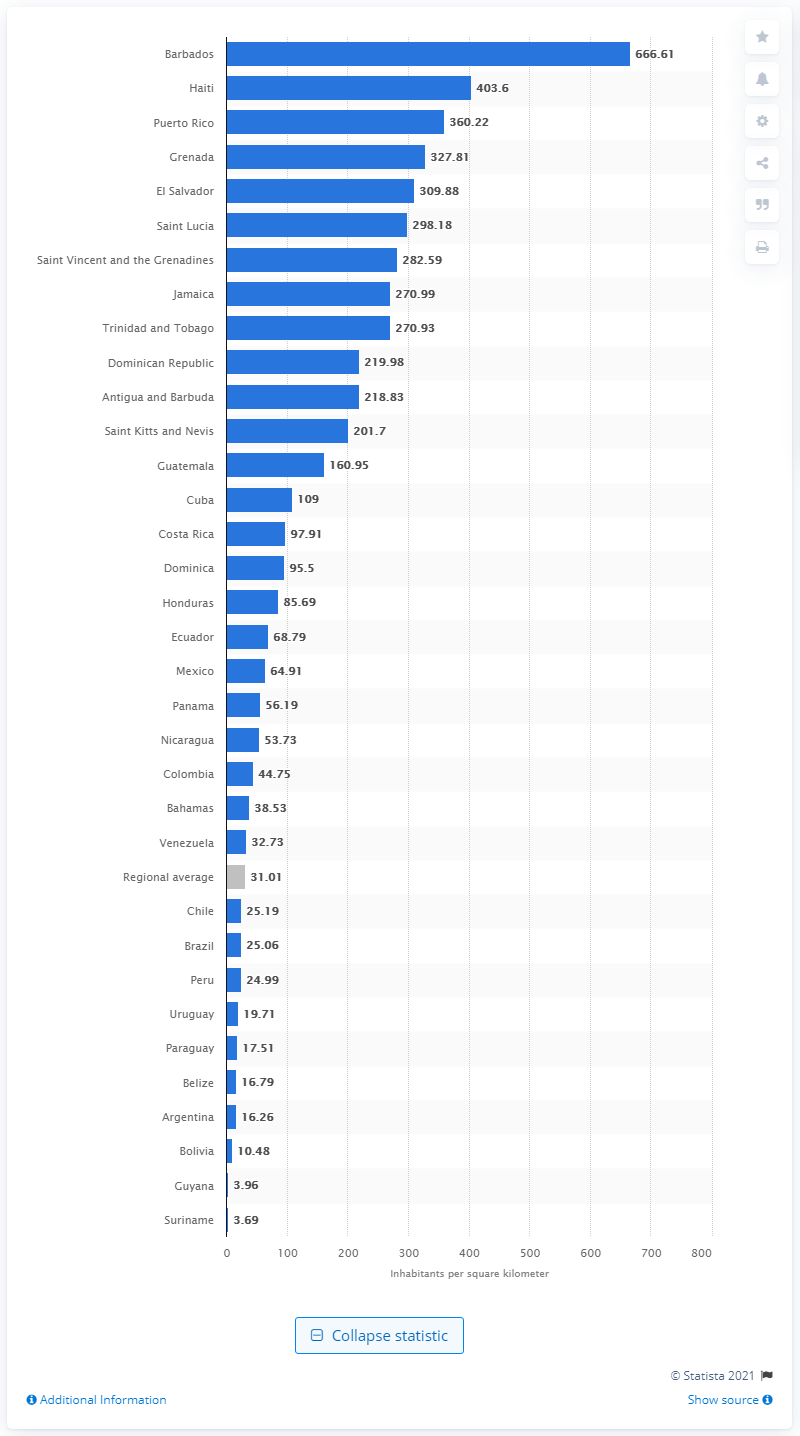Outline some significant characteristics in this image. According to data from 2018, Barbados was the densest country in Latin America and the Caribbean. 